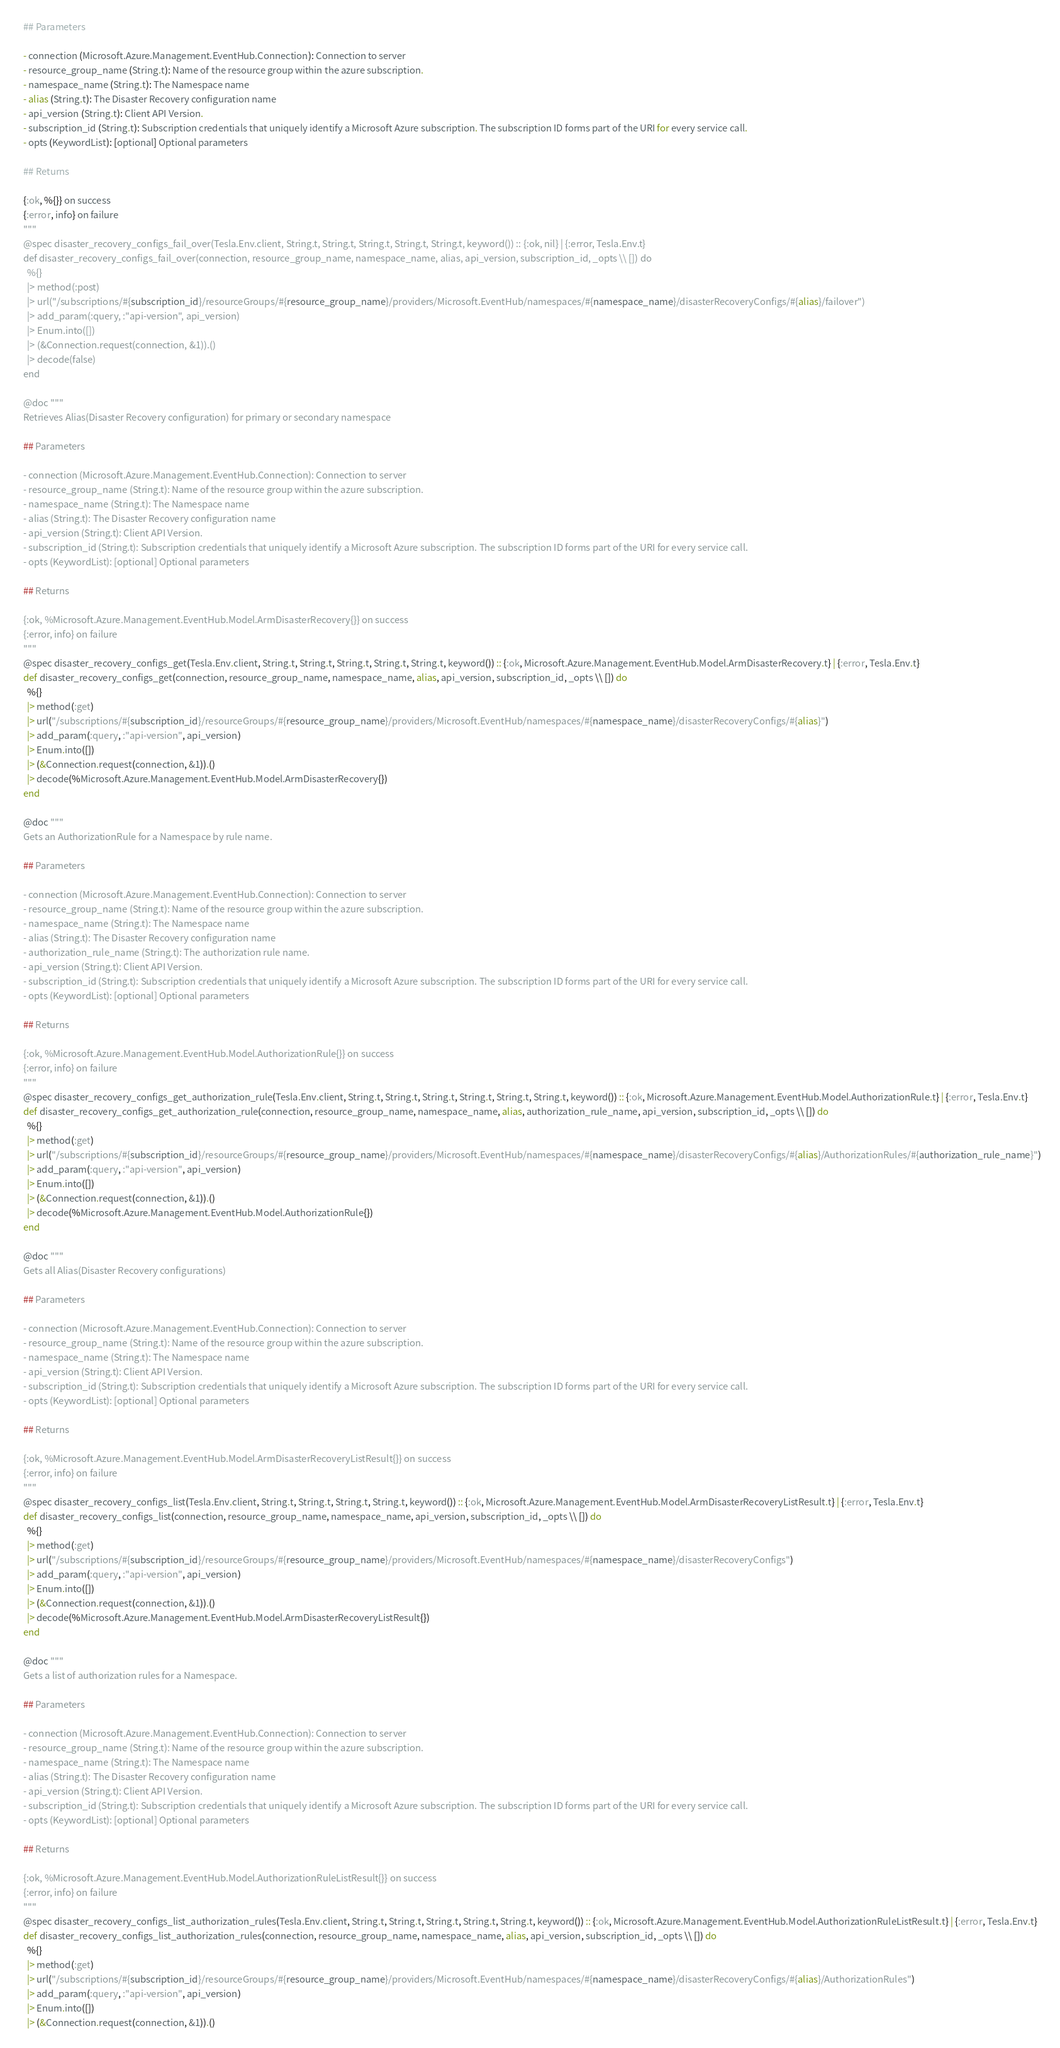Convert code to text. <code><loc_0><loc_0><loc_500><loc_500><_Elixir_>
  ## Parameters

  - connection (Microsoft.Azure.Management.EventHub.Connection): Connection to server
  - resource_group_name (String.t): Name of the resource group within the azure subscription.
  - namespace_name (String.t): The Namespace name
  - alias (String.t): The Disaster Recovery configuration name
  - api_version (String.t): Client API Version.
  - subscription_id (String.t): Subscription credentials that uniquely identify a Microsoft Azure subscription. The subscription ID forms part of the URI for every service call.
  - opts (KeywordList): [optional] Optional parameters

  ## Returns

  {:ok, %{}} on success
  {:error, info} on failure
  """
  @spec disaster_recovery_configs_fail_over(Tesla.Env.client, String.t, String.t, String.t, String.t, String.t, keyword()) :: {:ok, nil} | {:error, Tesla.Env.t}
  def disaster_recovery_configs_fail_over(connection, resource_group_name, namespace_name, alias, api_version, subscription_id, _opts \\ []) do
    %{}
    |> method(:post)
    |> url("/subscriptions/#{subscription_id}/resourceGroups/#{resource_group_name}/providers/Microsoft.EventHub/namespaces/#{namespace_name}/disasterRecoveryConfigs/#{alias}/failover")
    |> add_param(:query, :"api-version", api_version)
    |> Enum.into([])
    |> (&Connection.request(connection, &1)).()
    |> decode(false)
  end

  @doc """
  Retrieves Alias(Disaster Recovery configuration) for primary or secondary namespace

  ## Parameters

  - connection (Microsoft.Azure.Management.EventHub.Connection): Connection to server
  - resource_group_name (String.t): Name of the resource group within the azure subscription.
  - namespace_name (String.t): The Namespace name
  - alias (String.t): The Disaster Recovery configuration name
  - api_version (String.t): Client API Version.
  - subscription_id (String.t): Subscription credentials that uniquely identify a Microsoft Azure subscription. The subscription ID forms part of the URI for every service call.
  - opts (KeywordList): [optional] Optional parameters

  ## Returns

  {:ok, %Microsoft.Azure.Management.EventHub.Model.ArmDisasterRecovery{}} on success
  {:error, info} on failure
  """
  @spec disaster_recovery_configs_get(Tesla.Env.client, String.t, String.t, String.t, String.t, String.t, keyword()) :: {:ok, Microsoft.Azure.Management.EventHub.Model.ArmDisasterRecovery.t} | {:error, Tesla.Env.t}
  def disaster_recovery_configs_get(connection, resource_group_name, namespace_name, alias, api_version, subscription_id, _opts \\ []) do
    %{}
    |> method(:get)
    |> url("/subscriptions/#{subscription_id}/resourceGroups/#{resource_group_name}/providers/Microsoft.EventHub/namespaces/#{namespace_name}/disasterRecoveryConfigs/#{alias}")
    |> add_param(:query, :"api-version", api_version)
    |> Enum.into([])
    |> (&Connection.request(connection, &1)).()
    |> decode(%Microsoft.Azure.Management.EventHub.Model.ArmDisasterRecovery{})
  end

  @doc """
  Gets an AuthorizationRule for a Namespace by rule name.

  ## Parameters

  - connection (Microsoft.Azure.Management.EventHub.Connection): Connection to server
  - resource_group_name (String.t): Name of the resource group within the azure subscription.
  - namespace_name (String.t): The Namespace name
  - alias (String.t): The Disaster Recovery configuration name
  - authorization_rule_name (String.t): The authorization rule name.
  - api_version (String.t): Client API Version.
  - subscription_id (String.t): Subscription credentials that uniquely identify a Microsoft Azure subscription. The subscription ID forms part of the URI for every service call.
  - opts (KeywordList): [optional] Optional parameters

  ## Returns

  {:ok, %Microsoft.Azure.Management.EventHub.Model.AuthorizationRule{}} on success
  {:error, info} on failure
  """
  @spec disaster_recovery_configs_get_authorization_rule(Tesla.Env.client, String.t, String.t, String.t, String.t, String.t, String.t, keyword()) :: {:ok, Microsoft.Azure.Management.EventHub.Model.AuthorizationRule.t} | {:error, Tesla.Env.t}
  def disaster_recovery_configs_get_authorization_rule(connection, resource_group_name, namespace_name, alias, authorization_rule_name, api_version, subscription_id, _opts \\ []) do
    %{}
    |> method(:get)
    |> url("/subscriptions/#{subscription_id}/resourceGroups/#{resource_group_name}/providers/Microsoft.EventHub/namespaces/#{namespace_name}/disasterRecoveryConfigs/#{alias}/AuthorizationRules/#{authorization_rule_name}")
    |> add_param(:query, :"api-version", api_version)
    |> Enum.into([])
    |> (&Connection.request(connection, &1)).()
    |> decode(%Microsoft.Azure.Management.EventHub.Model.AuthorizationRule{})
  end

  @doc """
  Gets all Alias(Disaster Recovery configurations)

  ## Parameters

  - connection (Microsoft.Azure.Management.EventHub.Connection): Connection to server
  - resource_group_name (String.t): Name of the resource group within the azure subscription.
  - namespace_name (String.t): The Namespace name
  - api_version (String.t): Client API Version.
  - subscription_id (String.t): Subscription credentials that uniquely identify a Microsoft Azure subscription. The subscription ID forms part of the URI for every service call.
  - opts (KeywordList): [optional] Optional parameters

  ## Returns

  {:ok, %Microsoft.Azure.Management.EventHub.Model.ArmDisasterRecoveryListResult{}} on success
  {:error, info} on failure
  """
  @spec disaster_recovery_configs_list(Tesla.Env.client, String.t, String.t, String.t, String.t, keyword()) :: {:ok, Microsoft.Azure.Management.EventHub.Model.ArmDisasterRecoveryListResult.t} | {:error, Tesla.Env.t}
  def disaster_recovery_configs_list(connection, resource_group_name, namespace_name, api_version, subscription_id, _opts \\ []) do
    %{}
    |> method(:get)
    |> url("/subscriptions/#{subscription_id}/resourceGroups/#{resource_group_name}/providers/Microsoft.EventHub/namespaces/#{namespace_name}/disasterRecoveryConfigs")
    |> add_param(:query, :"api-version", api_version)
    |> Enum.into([])
    |> (&Connection.request(connection, &1)).()
    |> decode(%Microsoft.Azure.Management.EventHub.Model.ArmDisasterRecoveryListResult{})
  end

  @doc """
  Gets a list of authorization rules for a Namespace.

  ## Parameters

  - connection (Microsoft.Azure.Management.EventHub.Connection): Connection to server
  - resource_group_name (String.t): Name of the resource group within the azure subscription.
  - namespace_name (String.t): The Namespace name
  - alias (String.t): The Disaster Recovery configuration name
  - api_version (String.t): Client API Version.
  - subscription_id (String.t): Subscription credentials that uniquely identify a Microsoft Azure subscription. The subscription ID forms part of the URI for every service call.
  - opts (KeywordList): [optional] Optional parameters

  ## Returns

  {:ok, %Microsoft.Azure.Management.EventHub.Model.AuthorizationRuleListResult{}} on success
  {:error, info} on failure
  """
  @spec disaster_recovery_configs_list_authorization_rules(Tesla.Env.client, String.t, String.t, String.t, String.t, String.t, keyword()) :: {:ok, Microsoft.Azure.Management.EventHub.Model.AuthorizationRuleListResult.t} | {:error, Tesla.Env.t}
  def disaster_recovery_configs_list_authorization_rules(connection, resource_group_name, namespace_name, alias, api_version, subscription_id, _opts \\ []) do
    %{}
    |> method(:get)
    |> url("/subscriptions/#{subscription_id}/resourceGroups/#{resource_group_name}/providers/Microsoft.EventHub/namespaces/#{namespace_name}/disasterRecoveryConfigs/#{alias}/AuthorizationRules")
    |> add_param(:query, :"api-version", api_version)
    |> Enum.into([])
    |> (&Connection.request(connection, &1)).()</code> 